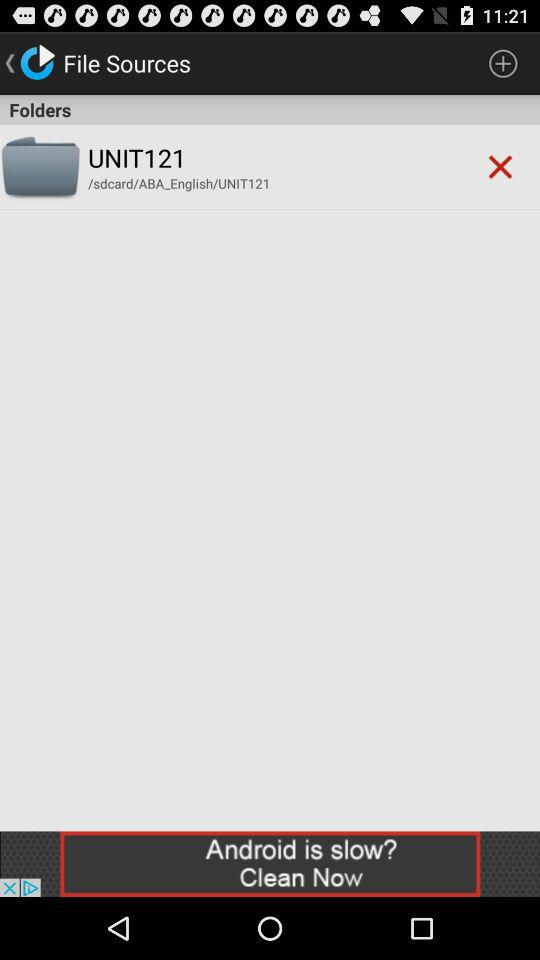What is the name of the folder? The name of the folder is "UNIT121". 